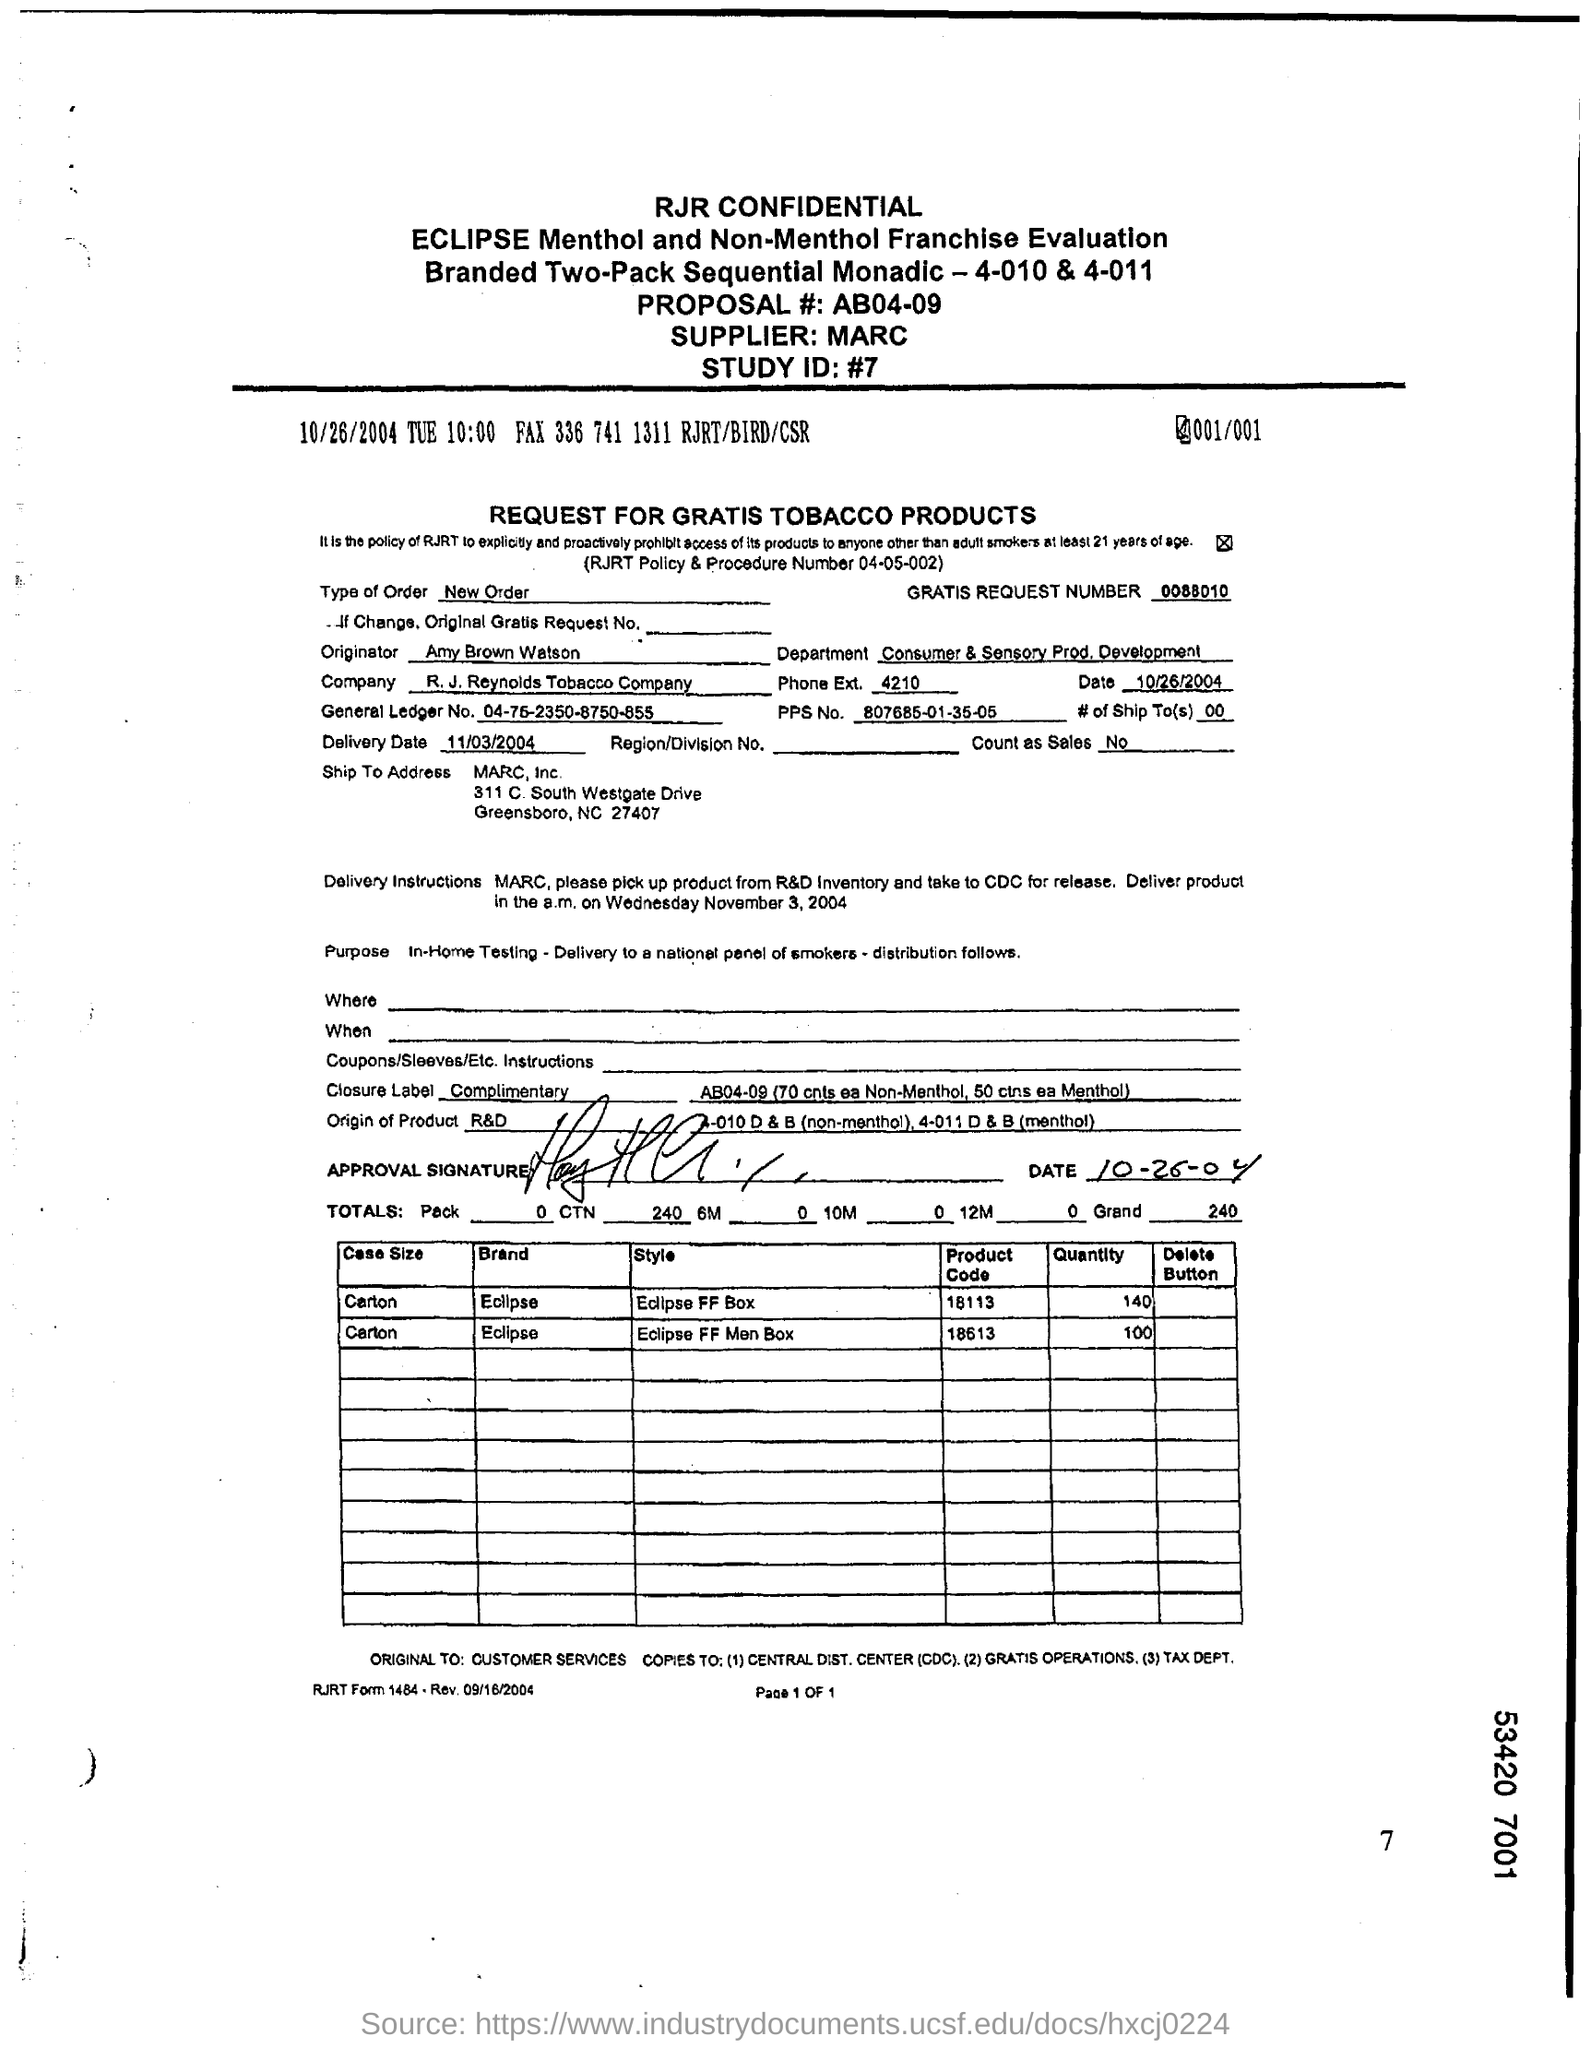What is the Proposal # ?
Offer a terse response. AB04-09. Who is the supplier?
Provide a succinct answer. MARC. What is the Study ID?
Your answer should be very brief. #7. What is the Type of Order?
Your answer should be compact. New Order. Who is the Originator?
Your answer should be compact. Amy Brown Watson. Which is the Department?
Ensure brevity in your answer.  Consumer & Sensory Prod. Development. 